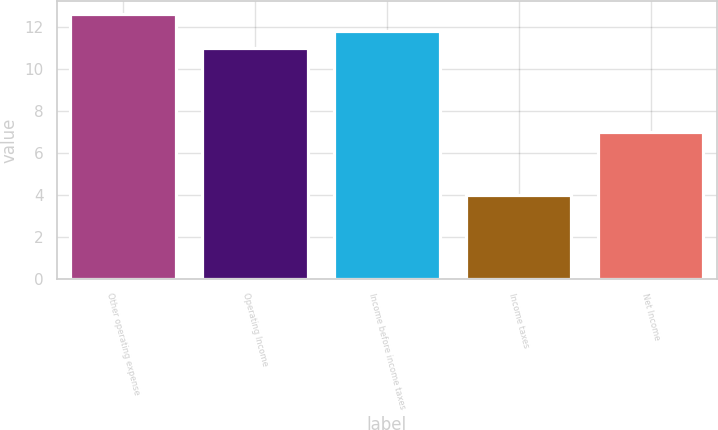<chart> <loc_0><loc_0><loc_500><loc_500><bar_chart><fcel>Other operating expense<fcel>Operating Income<fcel>Income before income taxes<fcel>Income taxes<fcel>Net Income<nl><fcel>12.6<fcel>11<fcel>11.8<fcel>4<fcel>7<nl></chart> 